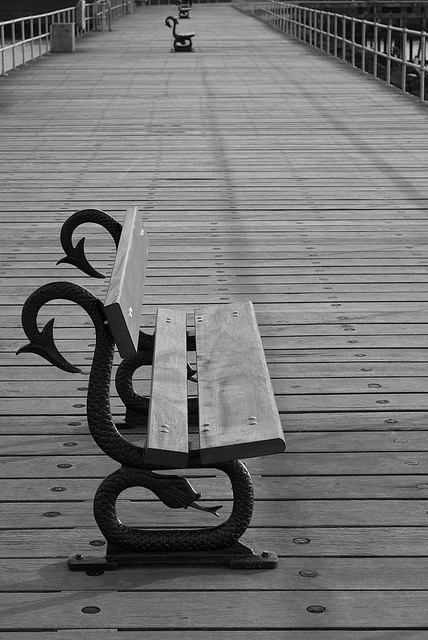Describe the objects in this image and their specific colors. I can see bench in black, darkgray, gray, and lightgray tones, bench in black, gray, darkgray, and lightgray tones, and bench in black and gray tones in this image. 